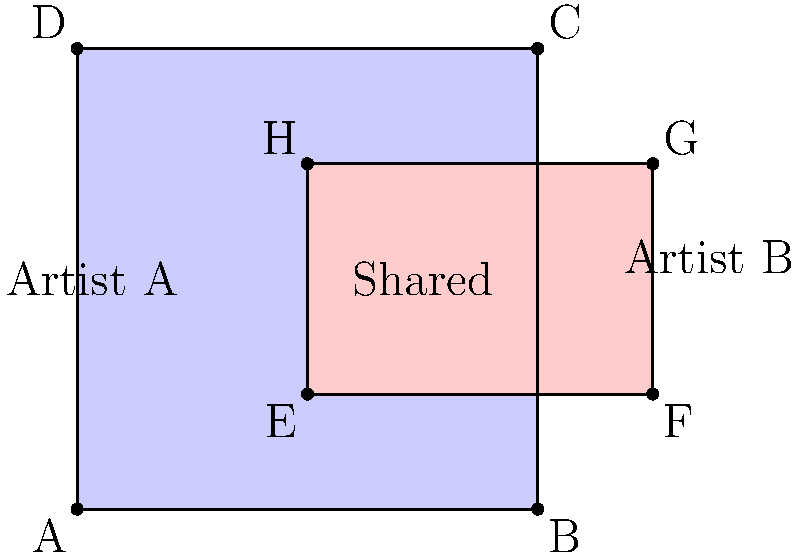In a collaborative music project, Artist A owns the rights to a 4x4 square area of musical elements, while Artist B owns the rights to a 3x4 rectangle area. The overlapping region represents shared copyright ownership. If the overlapping area is 2 square units, what percentage of Artist A's original copyright area is now shared with Artist B? Let's approach this step-by-step:

1) First, we need to calculate the total area of Artist A's square:
   Area of square = side length $\times$ side length
   $$ 4 \times 4 = 16 \text{ square units} $$

2) We're given that the overlapping area is 2 square units.

3) To find the percentage of Artist A's area that is shared, we use the formula:
   $$ \text{Percentage shared} = \frac{\text{Shared area}}{\text{Total area of Artist A}} \times 100\% $$

4) Plugging in our values:
   $$ \text{Percentage shared} = \frac{2}{16} \times 100\% $$

5) Simplifying:
   $$ \text{Percentage shared} = 0.125 \times 100\% = 12.5\% $$

Therefore, 12.5% of Artist A's original copyright area is now shared with Artist B.
Answer: 12.5% 